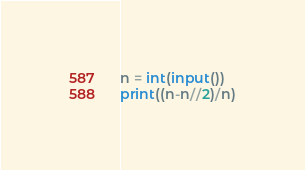Convert code to text. <code><loc_0><loc_0><loc_500><loc_500><_Python_>n = int(input())
print((n-n//2)/n)</code> 